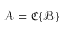Convert formula to latex. <formula><loc_0><loc_0><loc_500><loc_500>{ \mathcal { A } } = { \mathfrak { C } } \{ { \mathcal { B } } \}</formula> 